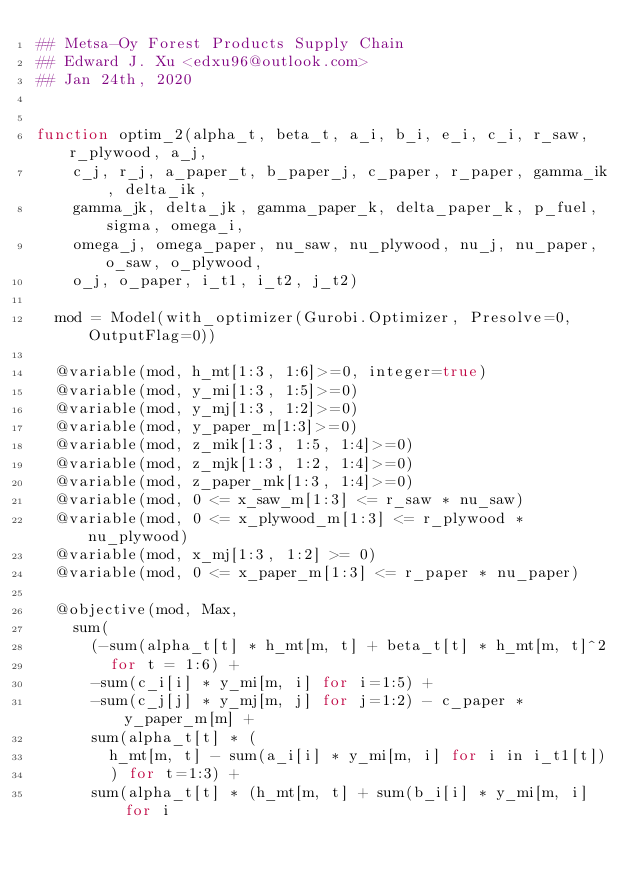Convert code to text. <code><loc_0><loc_0><loc_500><loc_500><_Julia_>## Metsa-Oy Forest Products Supply Chain
## Edward J. Xu <edxu96@outlook.com>
## Jan 24th, 2020


function optim_2(alpha_t, beta_t, a_i, b_i, e_i, c_i, r_saw, r_plywood, a_j,
    c_j, r_j, a_paper_t, b_paper_j, c_paper, r_paper, gamma_ik, delta_ik,
    gamma_jk, delta_jk, gamma_paper_k, delta_paper_k, p_fuel, sigma, omega_i,
    omega_j, omega_paper, nu_saw, nu_plywood, nu_j, nu_paper, o_saw, o_plywood,
    o_j, o_paper, i_t1, i_t2, j_t2)

  mod = Model(with_optimizer(Gurobi.Optimizer, Presolve=0, OutputFlag=0))

  @variable(mod, h_mt[1:3, 1:6]>=0, integer=true)
  @variable(mod, y_mi[1:3, 1:5]>=0)
  @variable(mod, y_mj[1:3, 1:2]>=0)
  @variable(mod, y_paper_m[1:3]>=0)
  @variable(mod, z_mik[1:3, 1:5, 1:4]>=0)
  @variable(mod, z_mjk[1:3, 1:2, 1:4]>=0)
  @variable(mod, z_paper_mk[1:3, 1:4]>=0)
  @variable(mod, 0 <= x_saw_m[1:3] <= r_saw * nu_saw)
  @variable(mod, 0 <= x_plywood_m[1:3] <= r_plywood * nu_plywood)
  @variable(mod, x_mj[1:3, 1:2] >= 0)
  @variable(mod, 0 <= x_paper_m[1:3] <= r_paper * nu_paper)

  @objective(mod, Max,
    sum(
      (-sum(alpha_t[t] * h_mt[m, t] + beta_t[t] * h_mt[m, t]^2
        for t = 1:6) +
      -sum(c_i[i] * y_mi[m, i] for i=1:5) +
      -sum(c_j[j] * y_mj[m, j] for j=1:2) - c_paper * y_paper_m[m] +
      sum(alpha_t[t] * (
        h_mt[m, t] - sum(a_i[i] * y_mi[m, i] for i in i_t1[t])
        ) for t=1:3) +
      sum(alpha_t[t] * (h_mt[m, t] + sum(b_i[i] * y_mi[m, i] for i</code> 